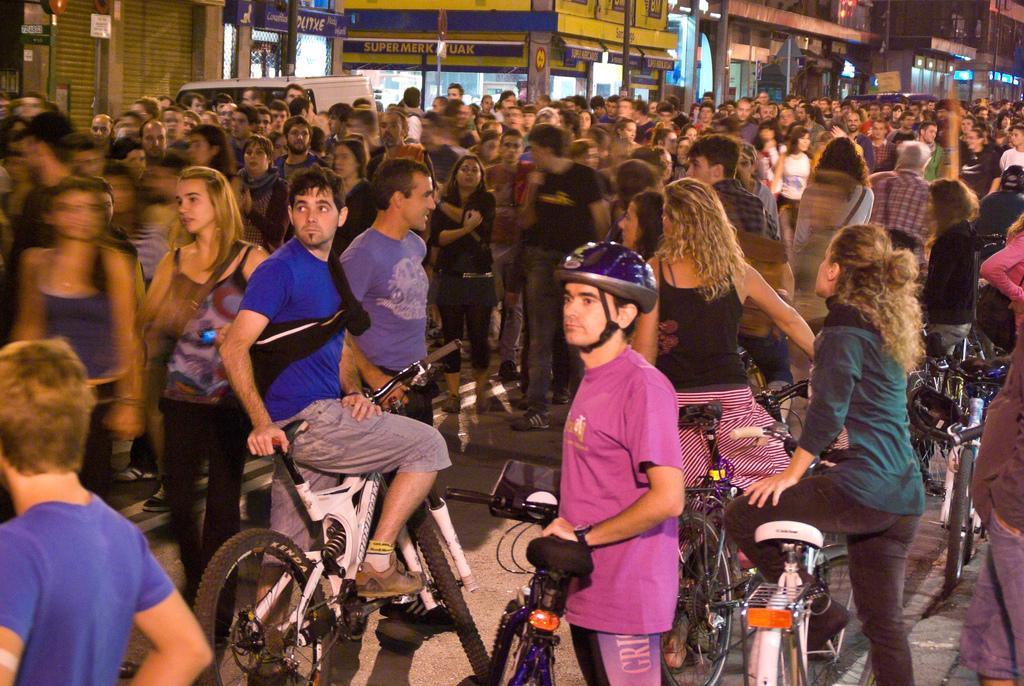What is happening in the image? There is a group of people in the image. Where are the people located? The people are standing on the road. Are there any people in the group doing something specific? Some people in the group are on bicycles. What type of can is being used by the fairies in the image? There are no fairies or cans present in the image. 